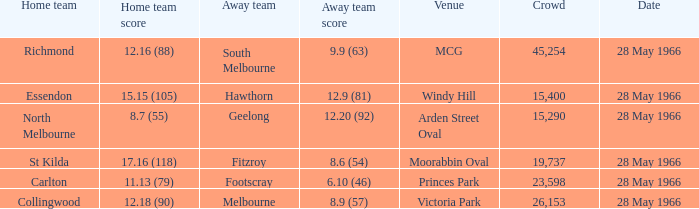Which Venue has a Home team of essendon? Windy Hill. 